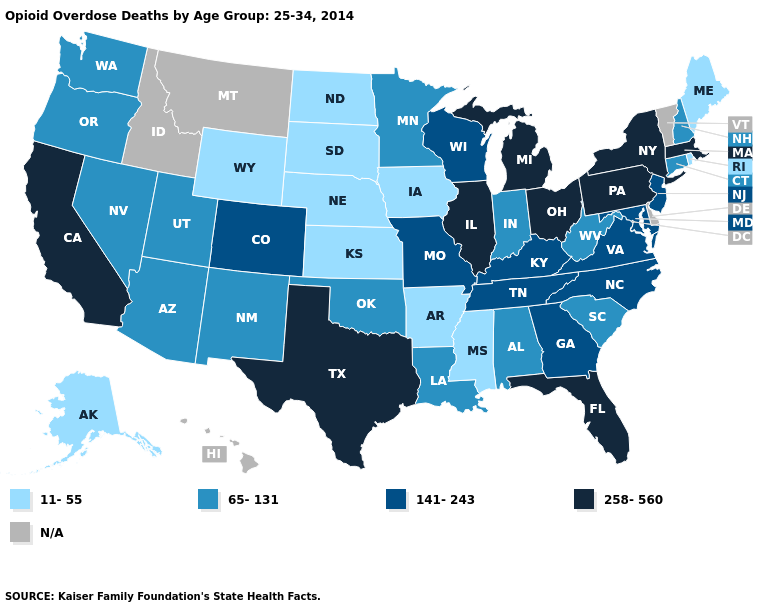What is the lowest value in the West?
Write a very short answer. 11-55. What is the value of North Dakota?
Answer briefly. 11-55. Among the states that border Massachusetts , which have the lowest value?
Give a very brief answer. Rhode Island. Name the states that have a value in the range 141-243?
Be succinct. Colorado, Georgia, Kentucky, Maryland, Missouri, New Jersey, North Carolina, Tennessee, Virginia, Wisconsin. What is the value of Wisconsin?
Be succinct. 141-243. Name the states that have a value in the range 11-55?
Answer briefly. Alaska, Arkansas, Iowa, Kansas, Maine, Mississippi, Nebraska, North Dakota, Rhode Island, South Dakota, Wyoming. Which states hav the highest value in the West?
Give a very brief answer. California. Does New York have the highest value in the USA?
Write a very short answer. Yes. Among the states that border North Dakota , does Minnesota have the lowest value?
Be succinct. No. What is the lowest value in the South?
Be succinct. 11-55. What is the value of Indiana?
Be succinct. 65-131. What is the lowest value in the Northeast?
Write a very short answer. 11-55. Does the map have missing data?
Quick response, please. Yes. What is the highest value in the South ?
Quick response, please. 258-560. 